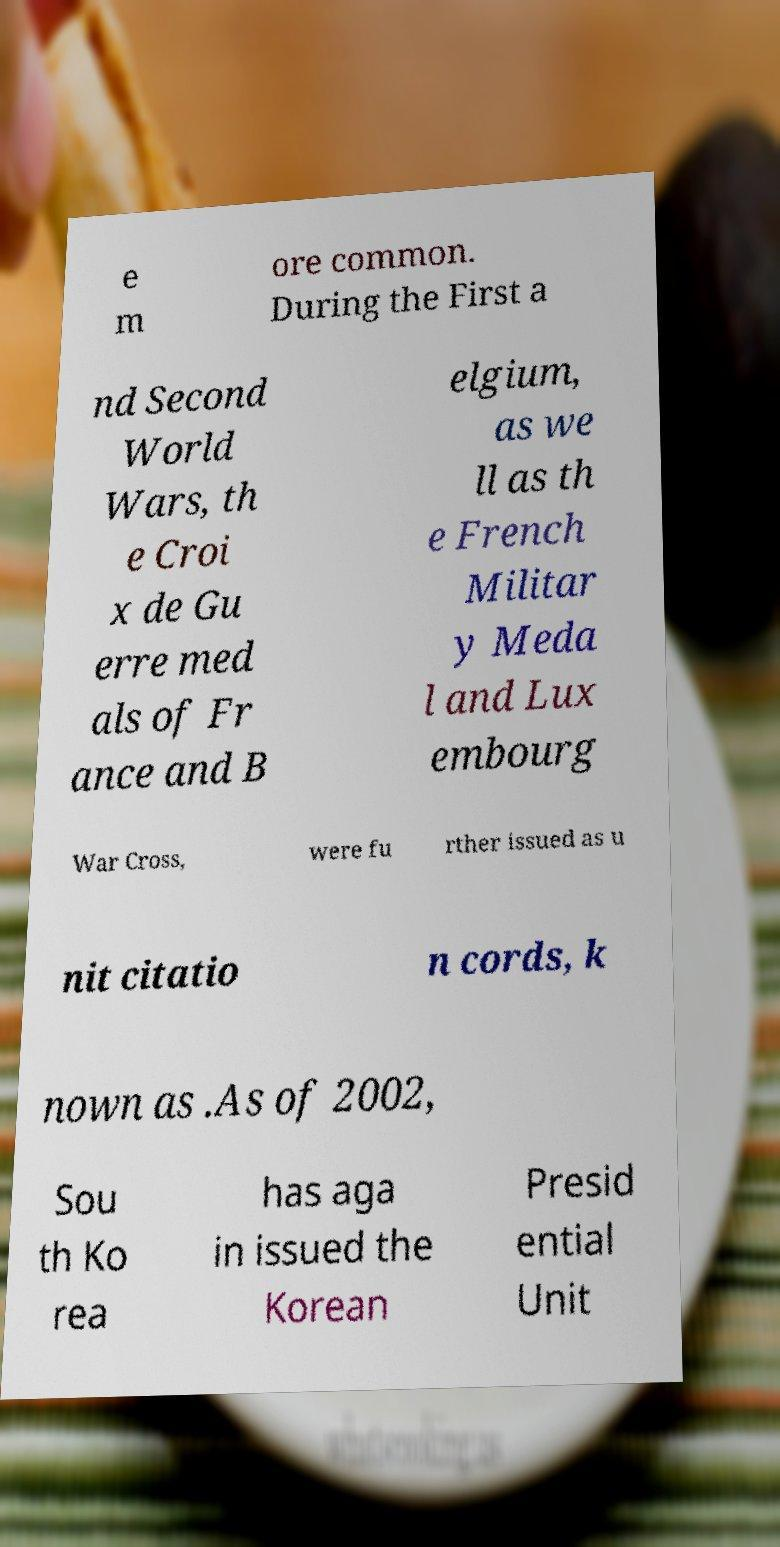Can you read and provide the text displayed in the image?This photo seems to have some interesting text. Can you extract and type it out for me? e m ore common. During the First a nd Second World Wars, th e Croi x de Gu erre med als of Fr ance and B elgium, as we ll as th e French Militar y Meda l and Lux embourg War Cross, were fu rther issued as u nit citatio n cords, k nown as .As of 2002, Sou th Ko rea has aga in issued the Korean Presid ential Unit 